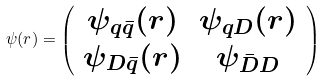<formula> <loc_0><loc_0><loc_500><loc_500>\psi ( r ) = \left ( \begin{array} { c c } { { \psi _ { q \bar { q } } ( r ) } } & { { \psi _ { q D } ( r ) } } \\ { { \psi _ { D \bar { q } } ( r ) } } & { { \psi _ { \bar { D } D } } } \end{array} \right )</formula> 